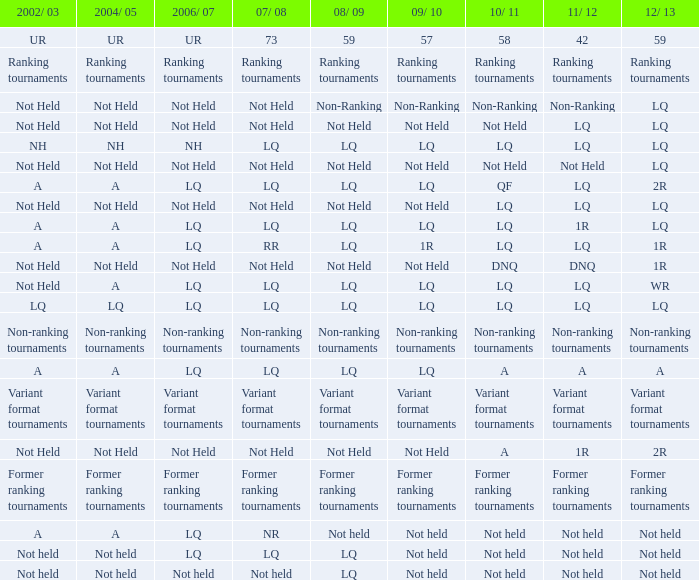Name the 2009/10 with 2011/12 of lq and 2008/09 of not held Not Held, Not Held. 